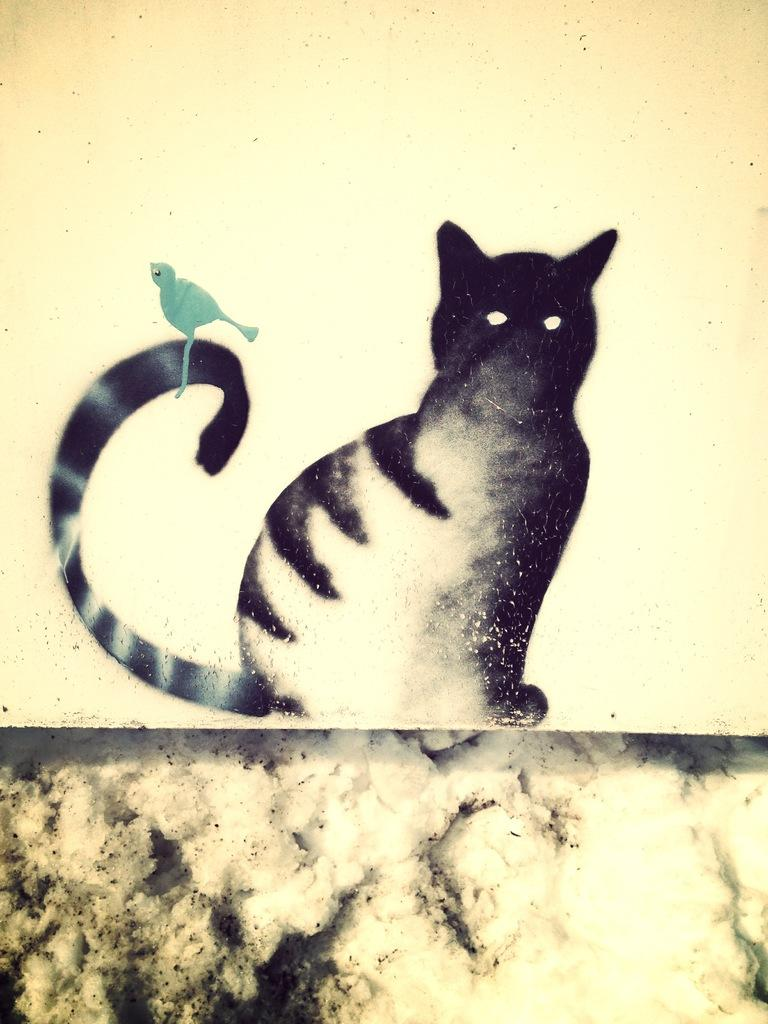What is the main subject of the painting in the image? The painting depicts a cat. Are there any other animals or objects in the painting? Yes, the painting also depicts a bird. What type of milk is being consumed by the cat in the painting? There is no milk present in the painting; it only depicts a cat and a bird. 